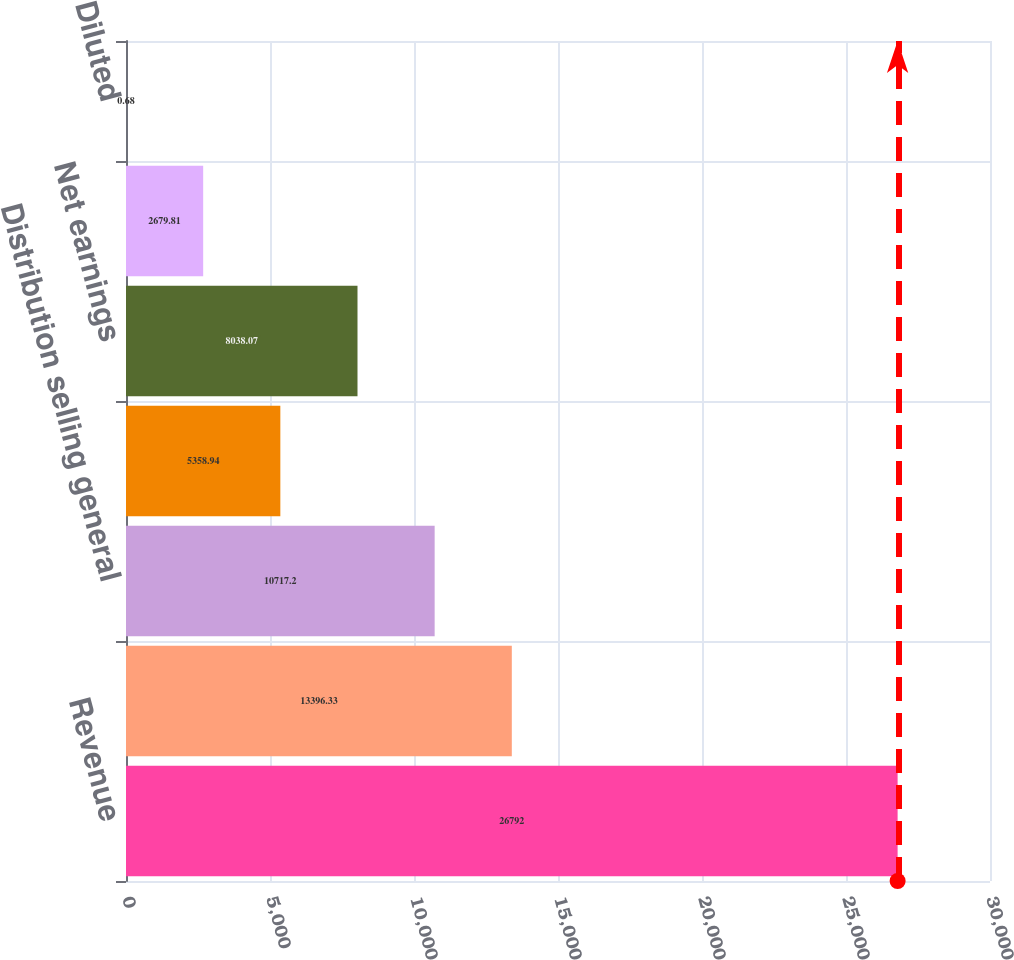Convert chart to OTSL. <chart><loc_0><loc_0><loc_500><loc_500><bar_chart><fcel>Revenue<fcel>Gross margin<fcel>Distribution selling general<fcel>Earnings from continuing<fcel>Net earnings<fcel>Basic<fcel>Diluted<nl><fcel>26792<fcel>13396.3<fcel>10717.2<fcel>5358.94<fcel>8038.07<fcel>2679.81<fcel>0.68<nl></chart> 